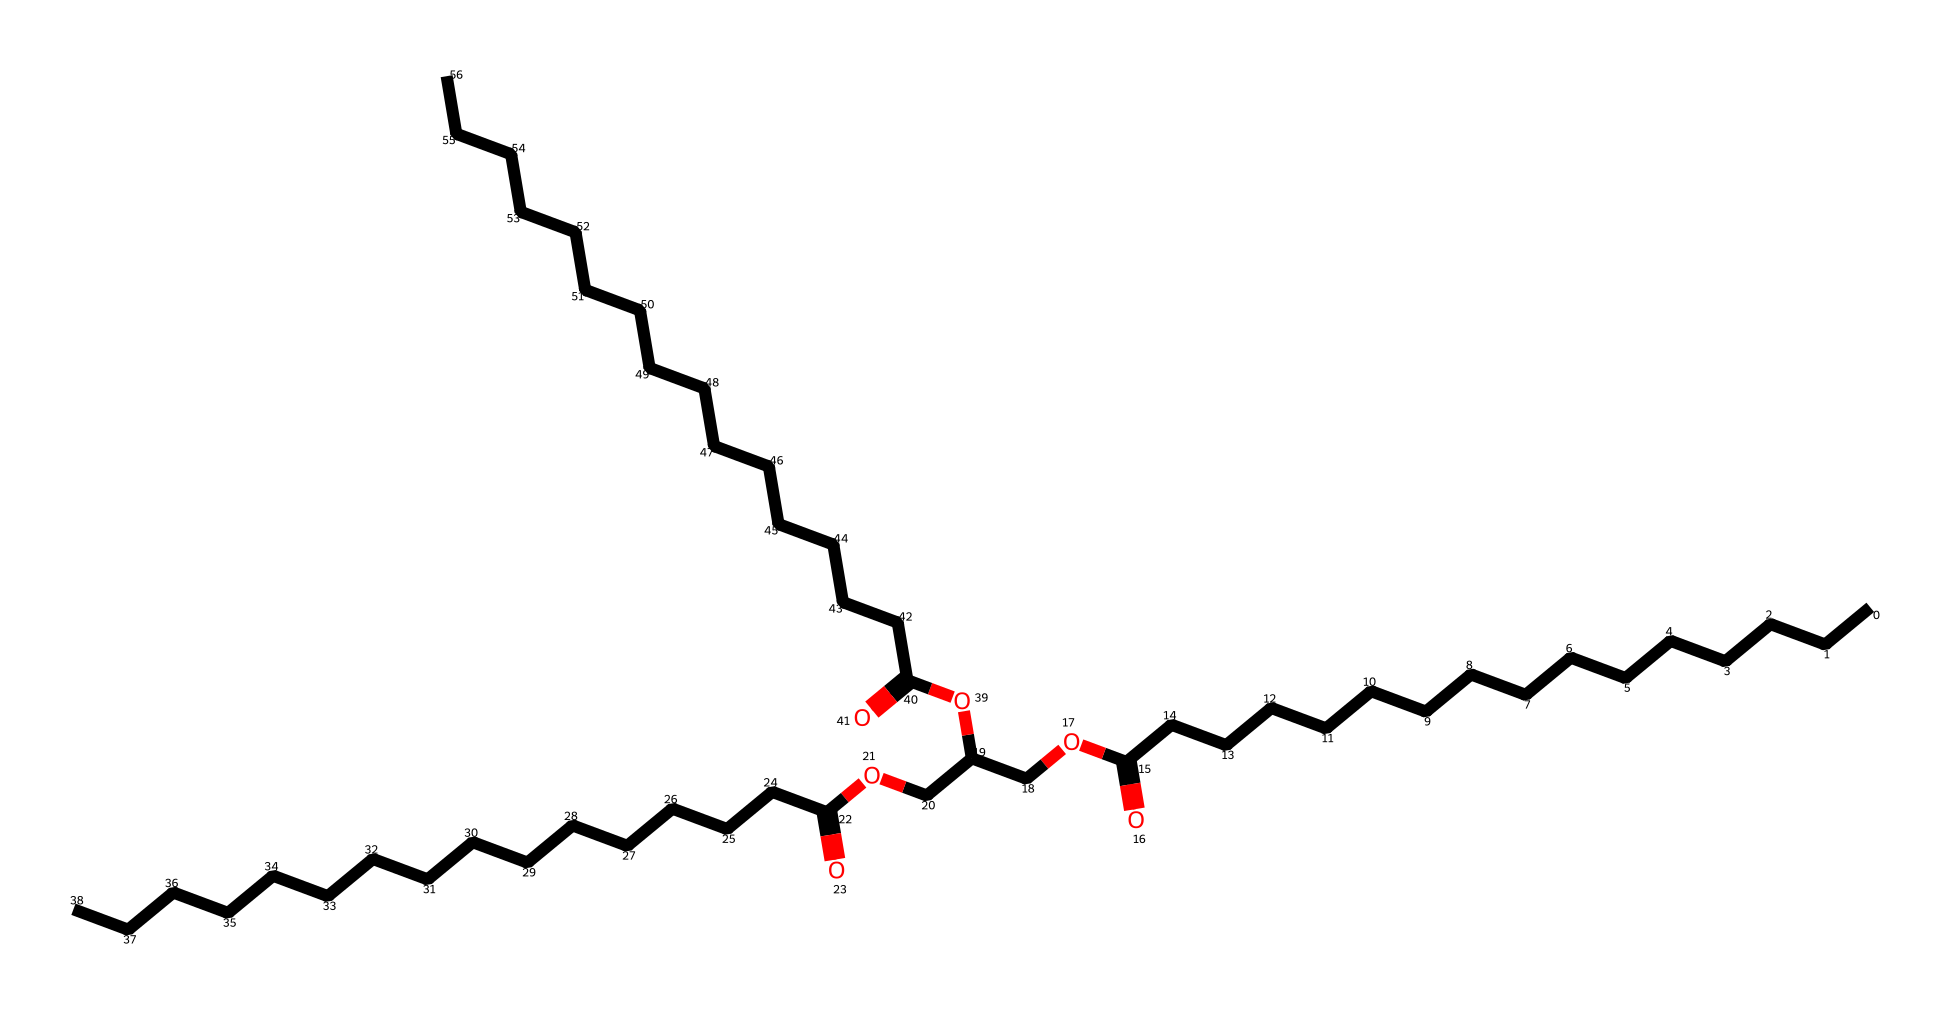What is the main functional group in this triglyceride? The presence of the -COOH (carboxylic acid) groups indicates that there are fatty acid chains, which are characteristic of triglycerides.
Answer: carboxylic acid How many carbon atoms are in the longest fatty acid chain? By analyzing the longest chain in the structure, there are 16 carbon atoms in the longest chain.
Answer: 16 What is the total number of ester linkages in this triglyceride? The chemical structure shows three distinct ester bonding groups connecting the fatty acid chains to a glycerol backbone, indicative of a triglyceride's structure.
Answer: 3 Which part of the structure determines its lipid classification? The presence of long hydrocarbon chains in the molecule indicates that it falls under the lipid classification due to its non-polar characteristics.
Answer: long hydrocarbon chains How many oxygen atoms are present in this triglyceride? Counting the number of oxygen atoms in the molecule, there are a total of 6 oxygen atoms noted in the structural representation.
Answer: 6 What type of lipid is this compound? Given its structure with glycerol and three fatty acids, it is classified specifically as a triglyceride.
Answer: triglyceride 